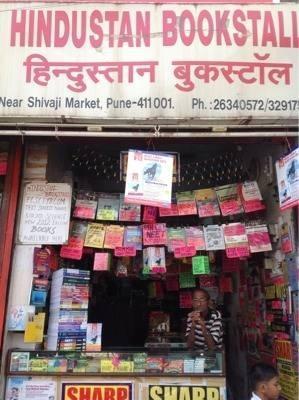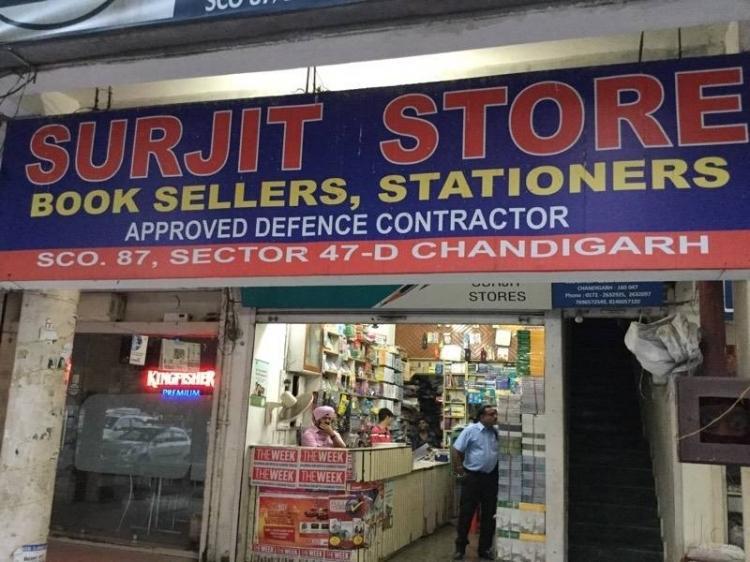The first image is the image on the left, the second image is the image on the right. Assess this claim about the two images: "The image to the left appears to feature an open air shop; no windows seem to bar the store from the elements.". Correct or not? Answer yes or no. Yes. The first image is the image on the left, the second image is the image on the right. For the images displayed, is the sentence "In one of the images a person is standing by books with no outside signage." factually correct? Answer yes or no. No. 